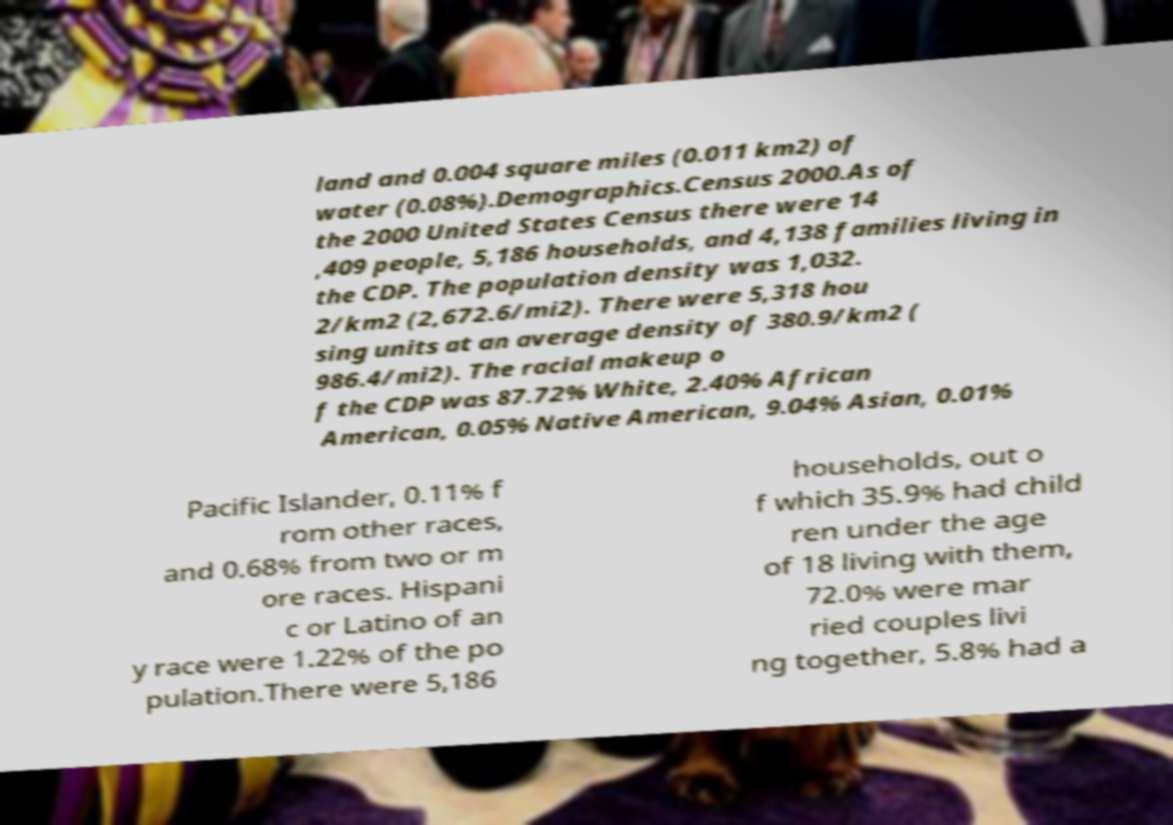Can you read and provide the text displayed in the image?This photo seems to have some interesting text. Can you extract and type it out for me? land and 0.004 square miles (0.011 km2) of water (0.08%).Demographics.Census 2000.As of the 2000 United States Census there were 14 ,409 people, 5,186 households, and 4,138 families living in the CDP. The population density was 1,032. 2/km2 (2,672.6/mi2). There were 5,318 hou sing units at an average density of 380.9/km2 ( 986.4/mi2). The racial makeup o f the CDP was 87.72% White, 2.40% African American, 0.05% Native American, 9.04% Asian, 0.01% Pacific Islander, 0.11% f rom other races, and 0.68% from two or m ore races. Hispani c or Latino of an y race were 1.22% of the po pulation.There were 5,186 households, out o f which 35.9% had child ren under the age of 18 living with them, 72.0% were mar ried couples livi ng together, 5.8% had a 